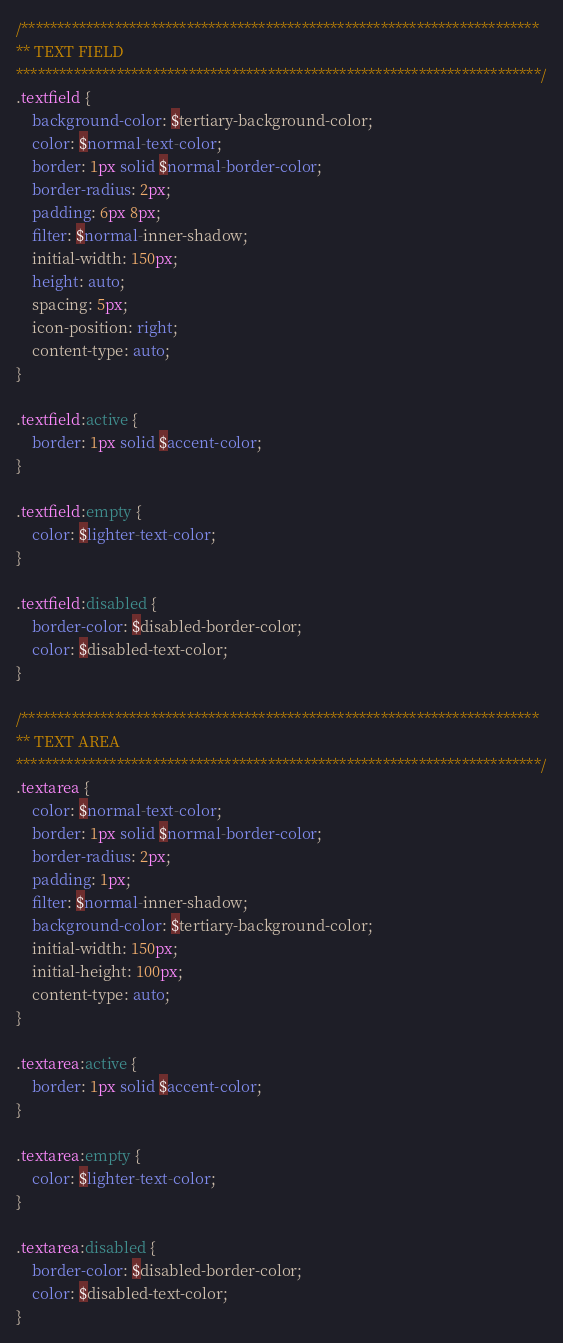Convert code to text. <code><loc_0><loc_0><loc_500><loc_500><_CSS_>/************************************************************************
** TEXT FIELD
*************************************************************************/
.textfield {
    background-color: $tertiary-background-color;
    color: $normal-text-color;
    border: 1px solid $normal-border-color;
    border-radius: 2px;
    padding: 6px 8px;
    filter: $normal-inner-shadow;
    initial-width: 150px;
    height: auto;
    spacing: 5px;
    icon-position: right;
    content-type: auto;
}

.textfield:active {
    border: 1px solid $accent-color;
}

.textfield:empty {
    color: $lighter-text-color;
}

.textfield:disabled {
    border-color: $disabled-border-color;
    color: $disabled-text-color;
}

/************************************************************************
** TEXT AREA
*************************************************************************/
.textarea {
    color: $normal-text-color;
    border: 1px solid $normal-border-color;
    border-radius: 2px;
    padding: 1px;
    filter: $normal-inner-shadow;
    background-color: $tertiary-background-color;
    initial-width: 150px;
    initial-height: 100px;
    content-type: auto;
}

.textarea:active {
    border: 1px solid $accent-color;
}

.textarea:empty {
    color: $lighter-text-color;
}

.textarea:disabled {
    border-color: $disabled-border-color;
    color: $disabled-text-color;
}</code> 